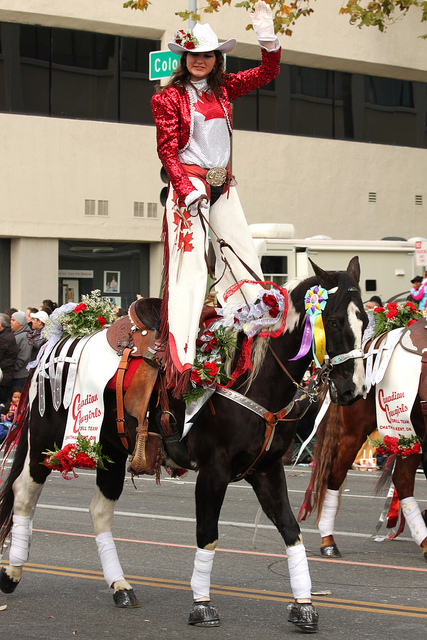What kind of decorations are on the horse? The horse is adorned with rich decorations that include red and white flowers, ribbons, and possibly foliage. There are also what appear to be awards or rosettes attached to the saddle blanket, hinting at the horse's participation or winning in show or competitive events.  Can you describe the event or context surrounding this image? While the image does not provide extensive context, the attire of the rider and decorations on the horse suggest this is a festive occasion, likely a parade. The presence of a street sign indicates this is an urban setting, and the decor could signify a holiday celebration or a cultural festival. 